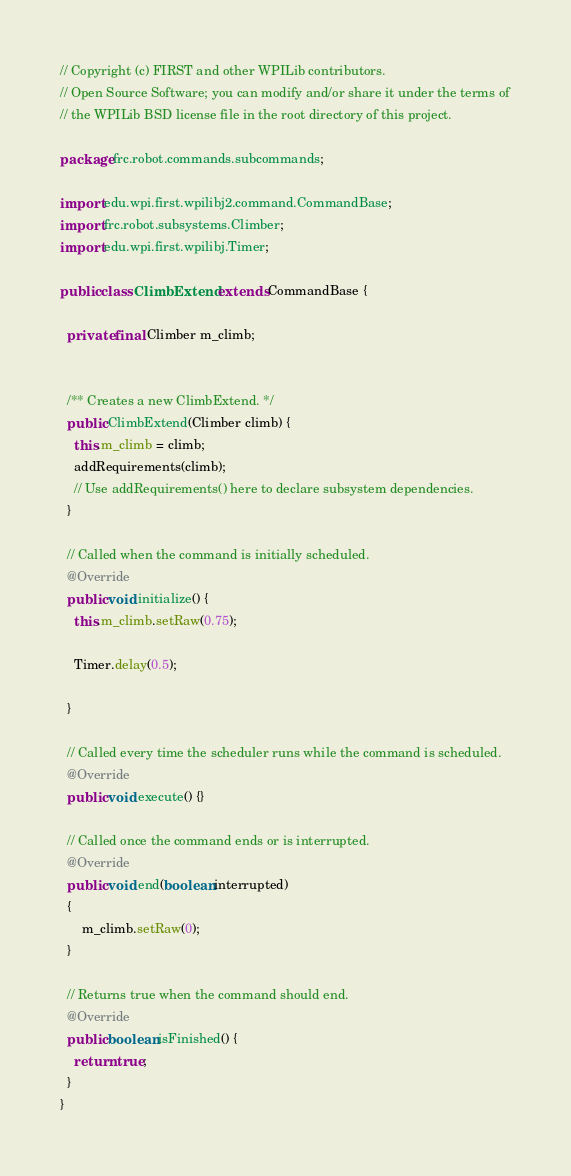Convert code to text. <code><loc_0><loc_0><loc_500><loc_500><_Java_>// Copyright (c) FIRST and other WPILib contributors.
// Open Source Software; you can modify and/or share it under the terms of
// the WPILib BSD license file in the root directory of this project.

package frc.robot.commands.subcommands;

import edu.wpi.first.wpilibj2.command.CommandBase;
import frc.robot.subsystems.Climber;
import edu.wpi.first.wpilibj.Timer;

public class ClimbExtend extends CommandBase {

  private final Climber m_climb;


  /** Creates a new ClimbExtend. */
  public ClimbExtend(Climber climb) {
    this.m_climb = climb;
    addRequirements(climb);
    // Use addRequirements() here to declare subsystem dependencies.
  }

  // Called when the command is initially scheduled.
  @Override
  public void initialize() {
    this.m_climb.setRaw(0.75);

    Timer.delay(0.5);

  }

  // Called every time the scheduler runs while the command is scheduled.
  @Override
  public void execute() {}

  // Called once the command ends or is interrupted.
  @Override
  public void end(boolean interrupted) 
  {
      m_climb.setRaw(0);
  }

  // Returns true when the command should end.
  @Override
  public boolean isFinished() {
    return true;
  }
}
</code> 